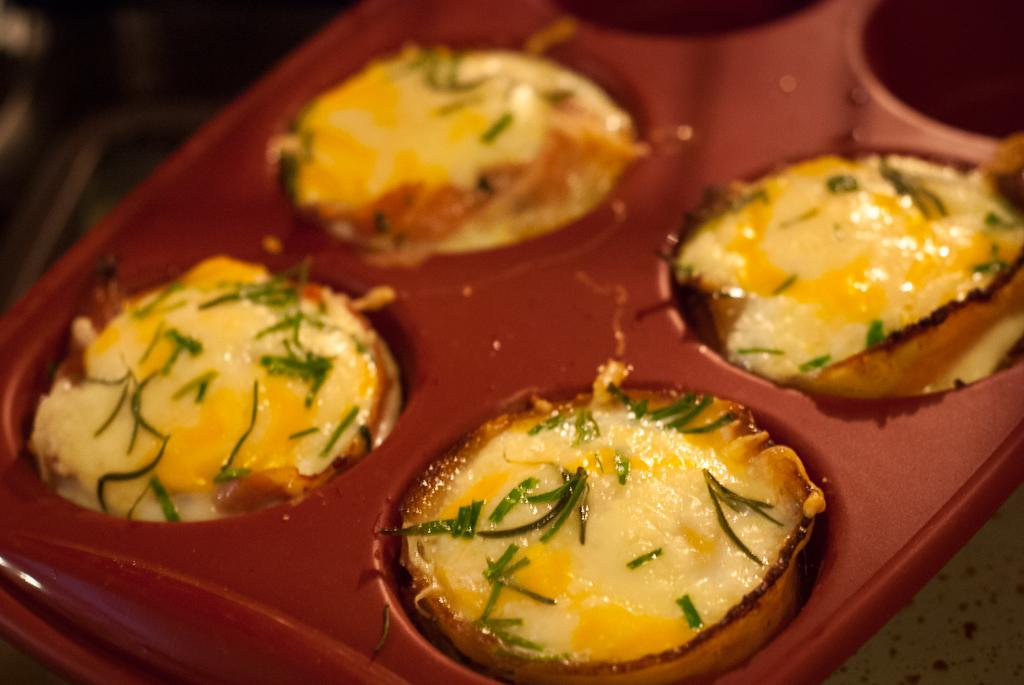What is placed in a tray in the image? There is food placed in a tray in the image. What type of garden does the queen visit in the image? There is no queen or garden present in the image; it only features food placed in a tray. 